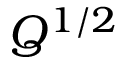<formula> <loc_0><loc_0><loc_500><loc_500>Q ^ { 1 / 2 }</formula> 